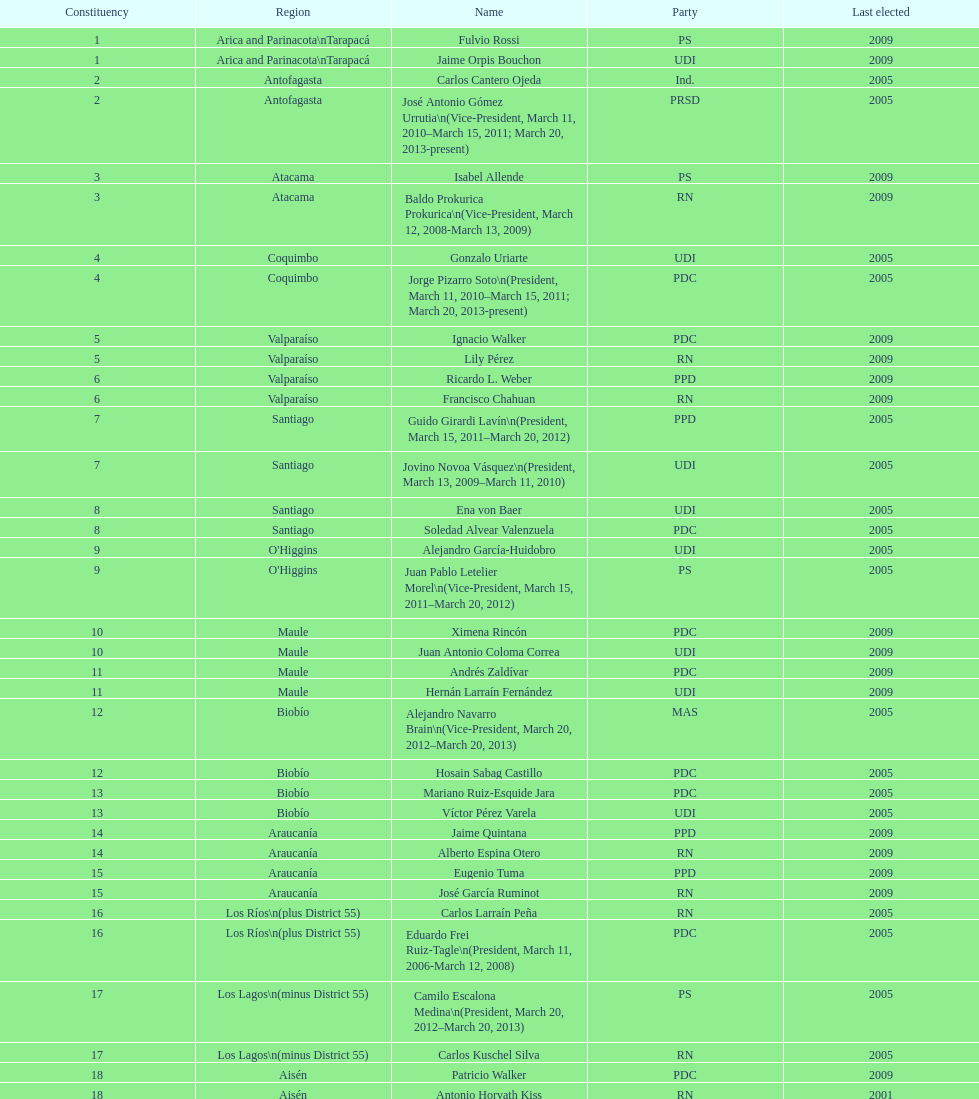What is the time difference in years between constituency 1 and 2? 4 years. 